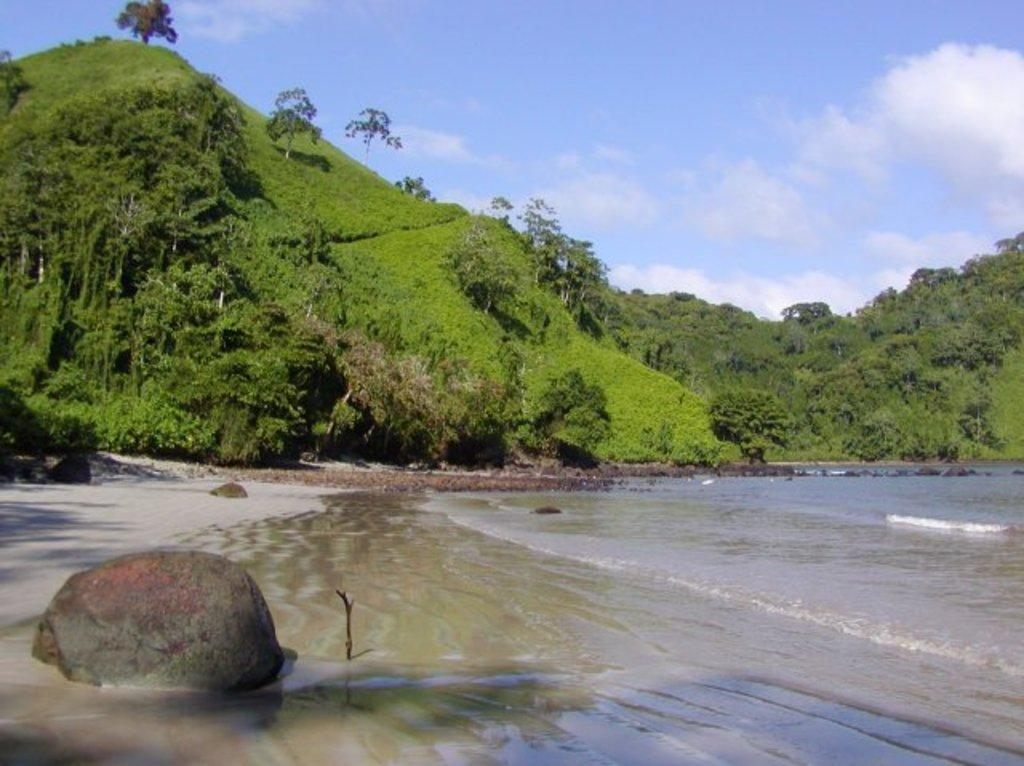What is the primary element visible in the image? There is water in the image. What other objects or features can be seen in the image? There is a stone, trees, grass, hills, and the sky visible in the image. Can you describe the background of the image? The background of the image includes trees, grass, hills, and the sky. What is the condition of the sky in the image? The sky is visible in the background of the image, and clouds are present. How many babies are holding apples in the image? There are no babies or apples present in the image. 